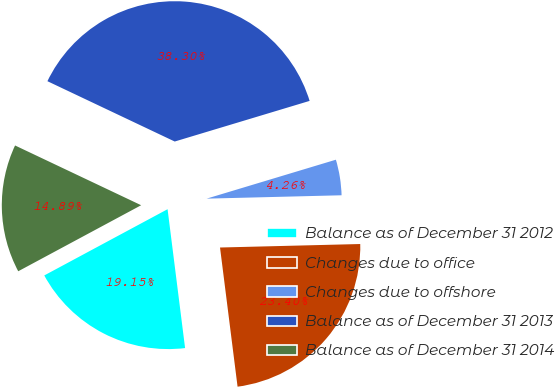Convert chart to OTSL. <chart><loc_0><loc_0><loc_500><loc_500><pie_chart><fcel>Balance as of December 31 2012<fcel>Changes due to office<fcel>Changes due to offshore<fcel>Balance as of December 31 2013<fcel>Balance as of December 31 2014<nl><fcel>19.15%<fcel>23.4%<fcel>4.26%<fcel>38.3%<fcel>14.89%<nl></chart> 